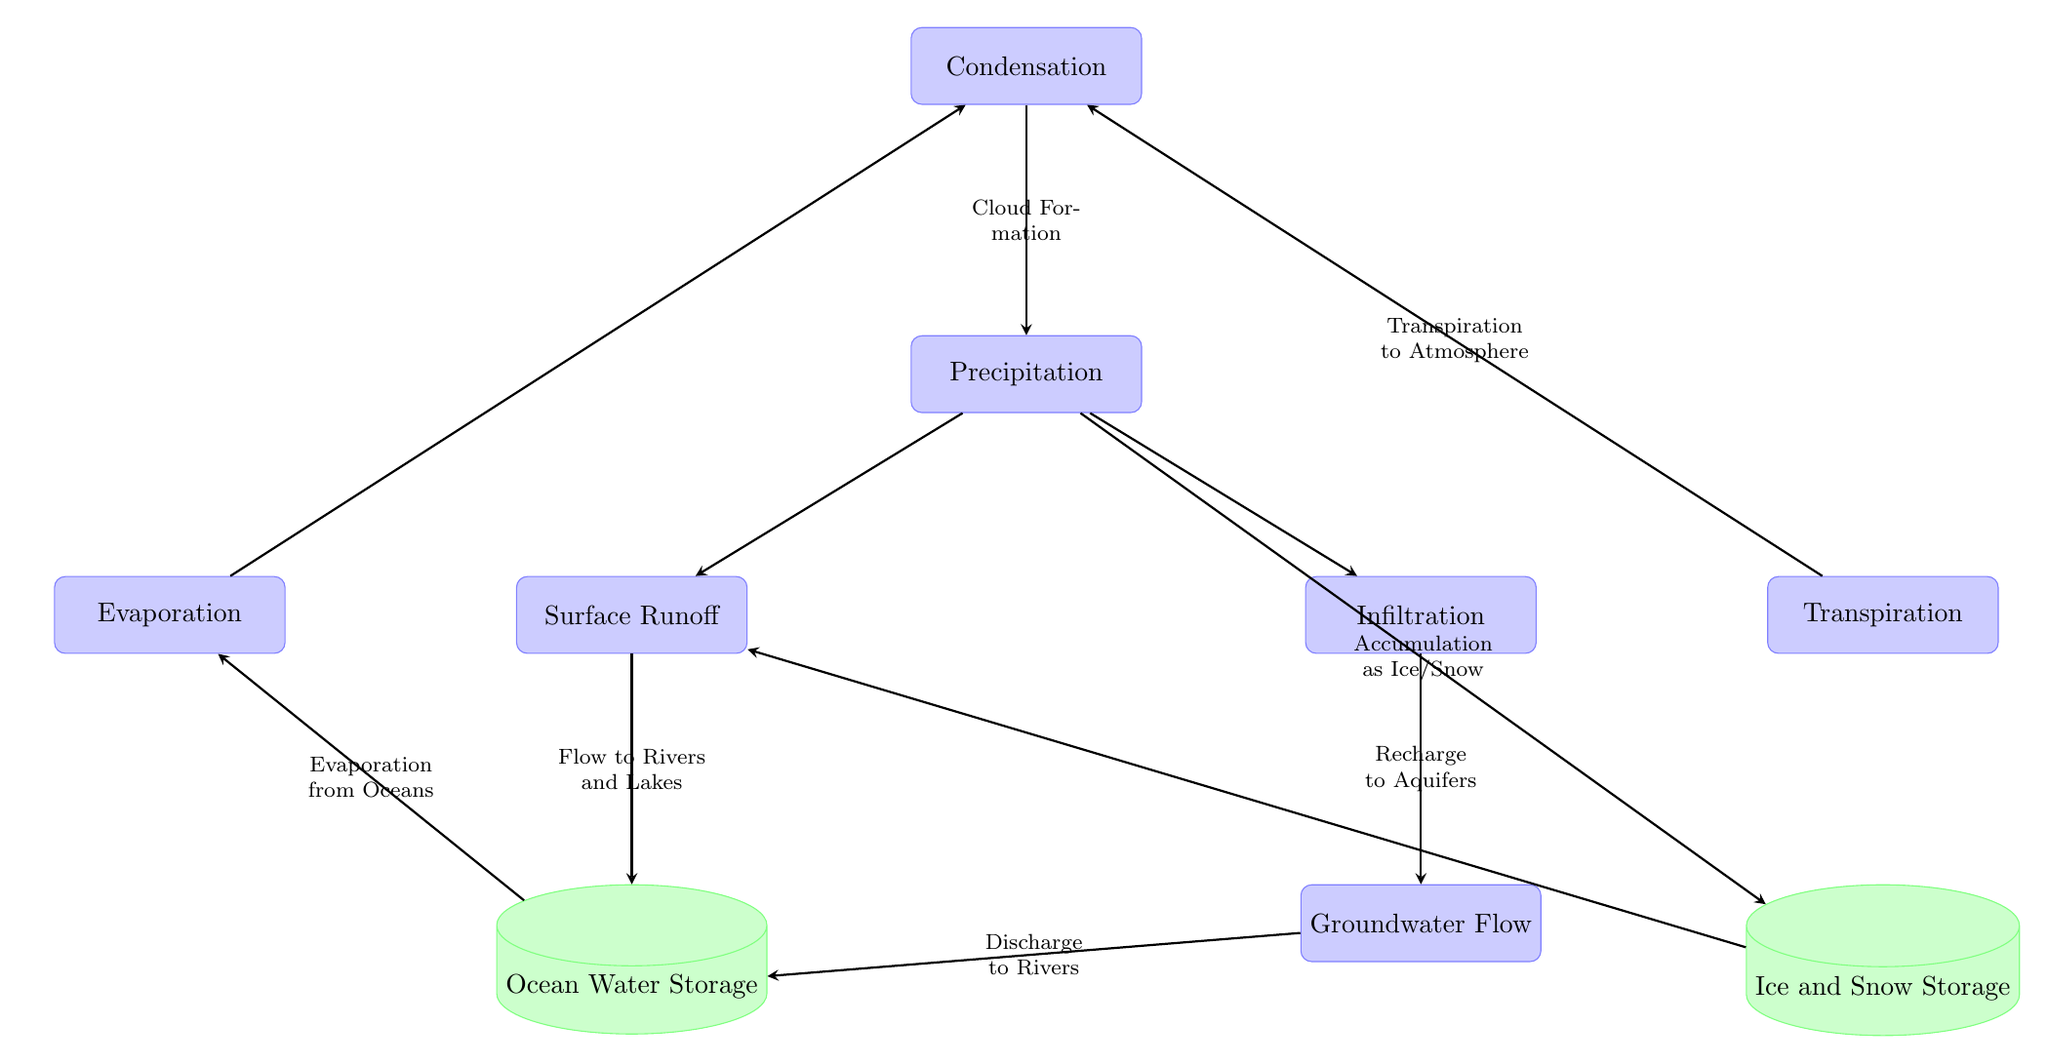What is the first step in the water cycle depicted in the diagram? The first step in the water cycle is "Condensation," as it leads to the formation of clouds, which then result in precipitation.
Answer: Condensation How many types of water storage are represented in the diagram? The diagram shows two types of water storage: "Ocean Water Storage" and "Ice and Snow Storage."
Answer: 2 What process occurs after "Precipitation" in the water cycle? After "Precipitation," the processes that occur are "Surface Runoff" and "Infiltration," which are both directly connected to the precipitation node.
Answer: Surface Runoff and Infiltration Which process is responsible for transferring water to the atmosphere following transpiration? The process that follows transpiration, transferring water to the atmosphere, is "Condensation," as transpiration contributes water vapor which eventually leads to cloud formation.
Answer: Condensation What flow relationship exists between "Groundwater Flow" and "Ocean Water Storage"? The relationship is that "Groundwater Flow" discharges to "Ocean Water Storage," indicating a flow of groundwater into the ocean.
Answer: Discharge What is the connection between "Evaporation" and "Precipitation"? The connection is that "Evaporation" leads to "Condensation," which in turn creates the conditions for "Precipitation," illustrating the cycle from evaporation to precipitation.
Answer: Evaporation to Condensation to Precipitation How does "Infiltration" contribute to water resources? "Infiltration" recharges aquifers, meaning it replenishes underground water supplies, which is critical for sustaining groundwater resources used by ecosystems and humans.
Answer: Recharge to Aquifers What role does "Surface Runoff" play in the water cycle? "Surface Runoff" is responsible for flowing water towards rivers and lakes, effectively transporting water that has fallen as precipitation across the land.
Answer: Flow to Rivers and Lakes What does the arrow from "Ice and Snow Storage" to "Surface Runoff" indicate? It indicates that melting ice and snow contribute directly to "Surface Runoff," thus adding to the flow of water on the surface eventually leading to oceans or lakes.
Answer: Contribution to Surface Runoff 